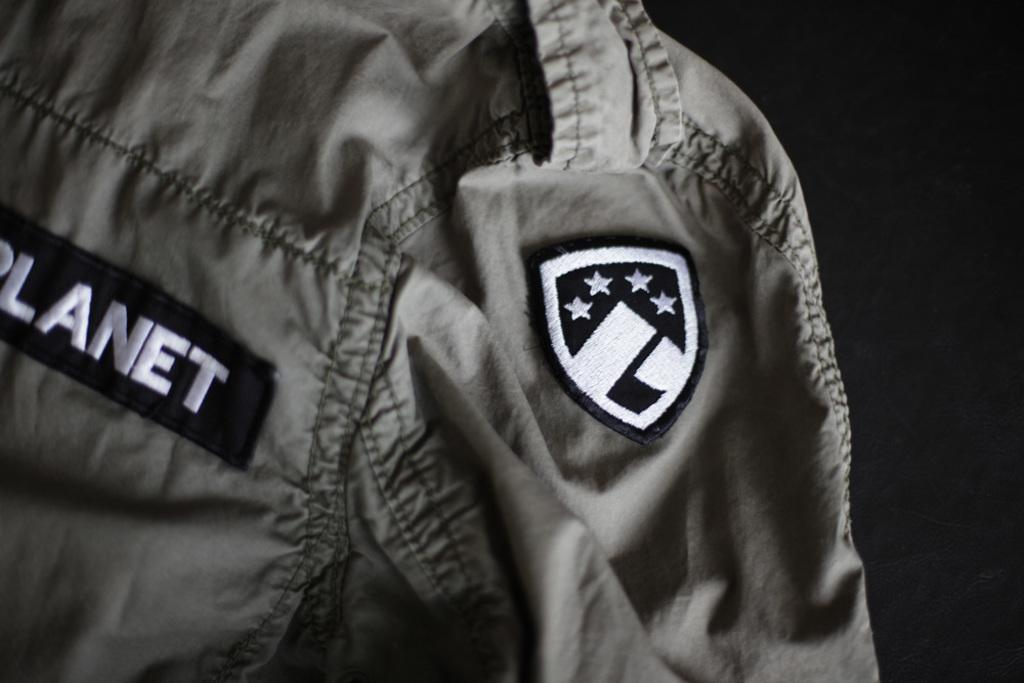<image>
Provide a brief description of the given image. The name tag on the uniform says Planet. 